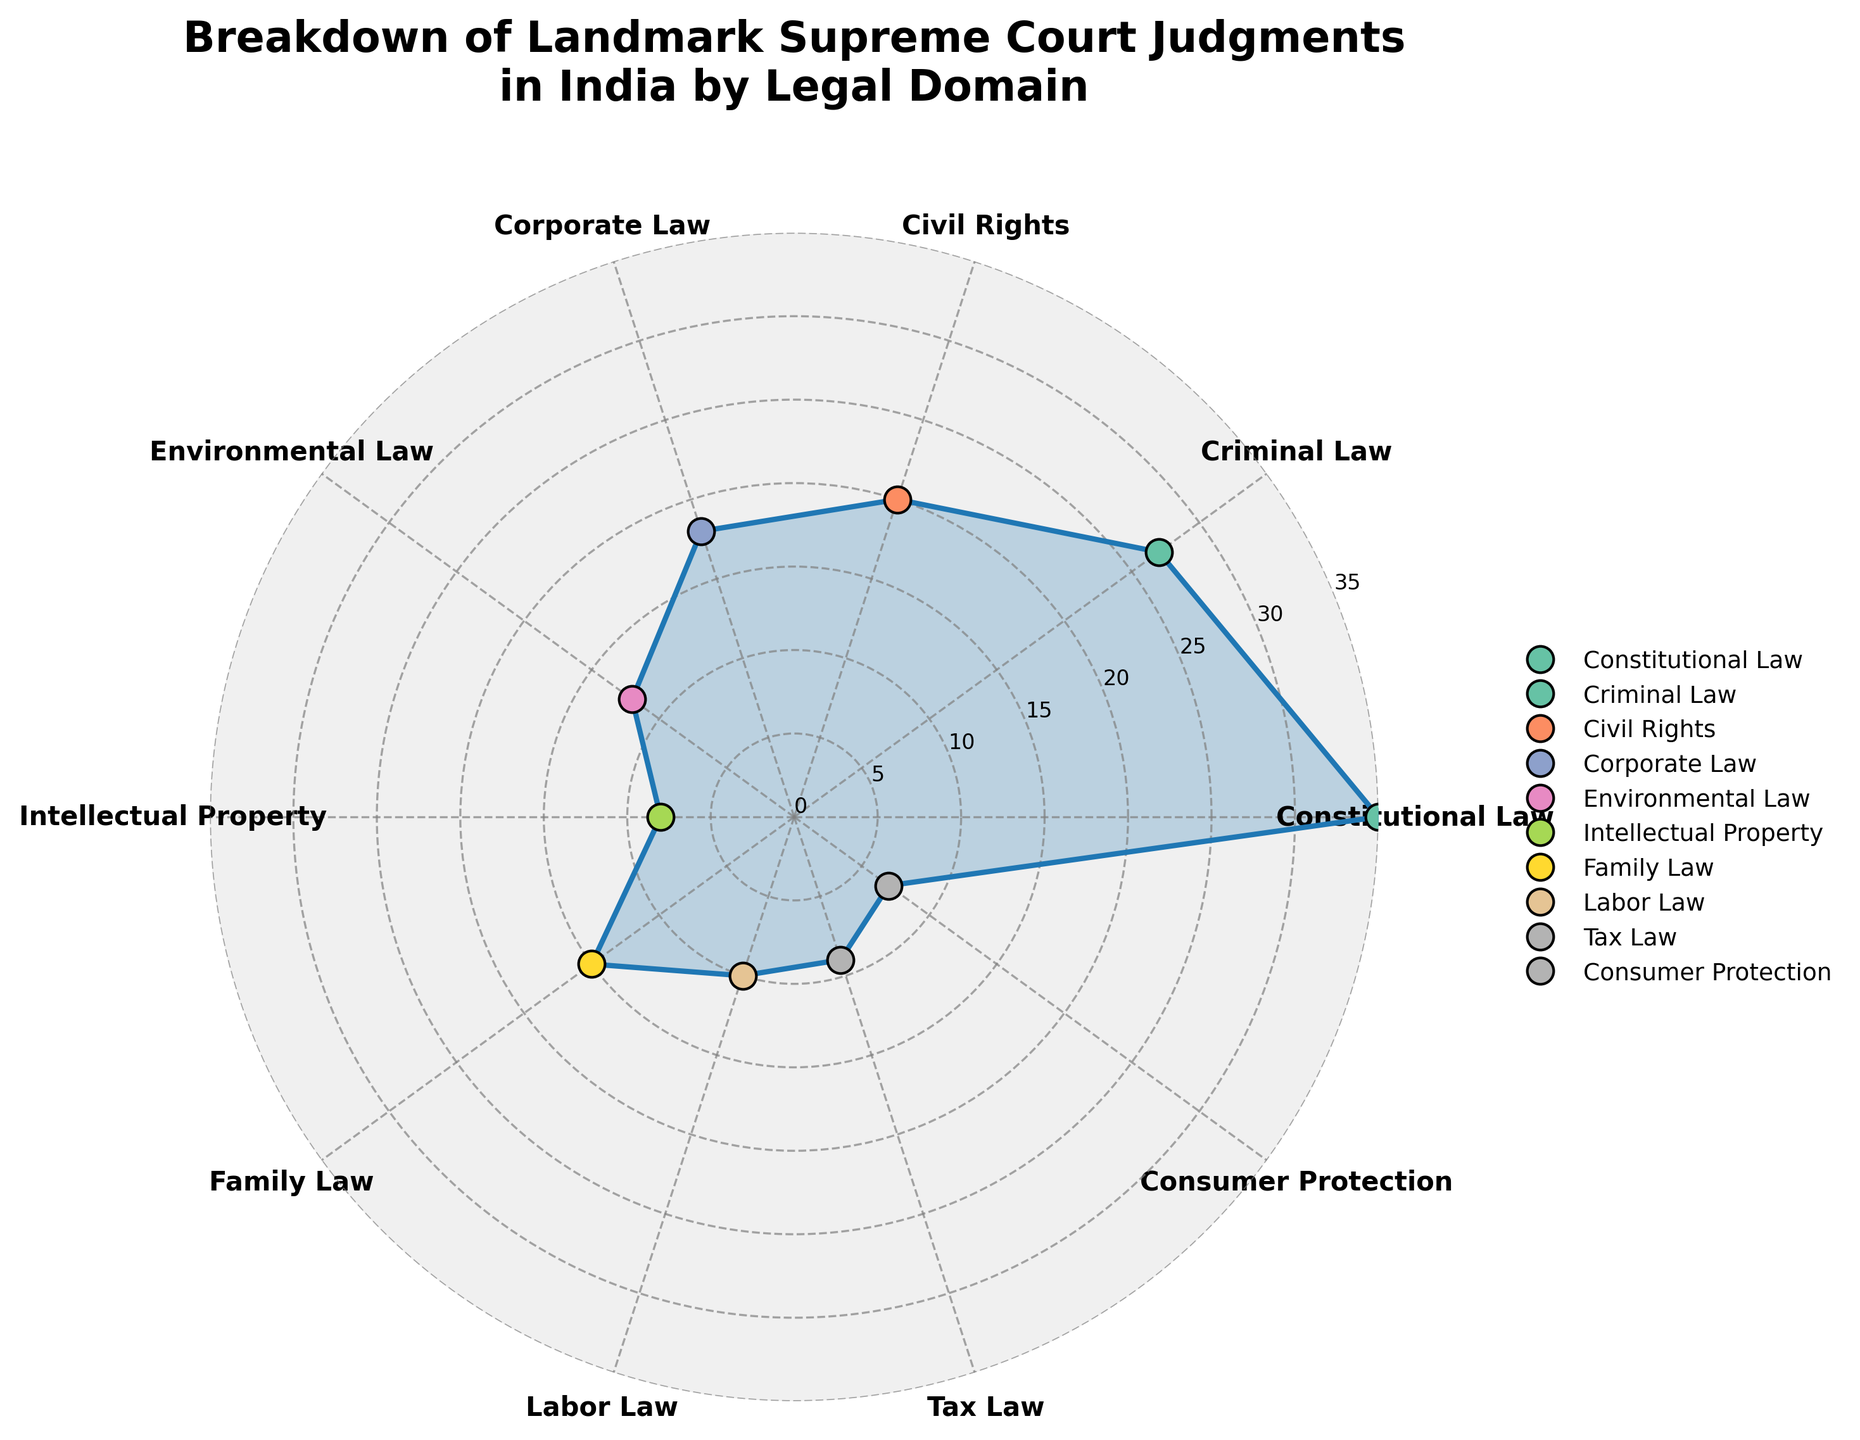What is the title of the figure? The title of the figure is prominently displayed at the top. It reads "Breakdown of Landmark Supreme Court Judgments in India by Legal Domain."
Answer: Breakdown of Landmark Supreme Court Judgments in India by Legal Domain How many legal domains are represented in the chart? By counting the labels around the polar area chart, you can see there are 10 different legal domains represented.
Answer: 10 Which legal domain has the highest number of landmark Supreme Court judgments? The segment with the largest length on the chart represents the legal domain with the highest number of judgments. This domain is labeled "Constitutional Law."
Answer: Constitutional Law What is the range of case counts for the legal domains shown in the chart? The range can be found by subtracting the smallest value (Consumer Protection, 7) from the largest value (Constitutional Law, 35).
Answer: 28 Which legal domains have fewer than 10 landmark Supreme Court judgments? From the plot, the labels with fewer than 10 judgments can be identified: Intellectual Property (8), Consumer Protection (7), and Tax Law (9).
Answer: Intellectual Property, Consumer Protection, and Tax Law How does the number of Criminal Law judgments compare to Environmental Law judgments? By observing the chart, Criminal Law has 27 judgments while Environmental Law has 12. Therefore, Criminal Law has more judgments.
Answer: Criminal Law has more judgments What is the median number of judgments among all legal domains? First, list the values: 35, 27, 20, 18, 15, 12, 10, 9, 8, 7. Since there are 10 values, the median will be the average of the 5th and 6th values in the ordered list: (15 + 12) / 2.
Answer: 13.5 How many legal domains have at least 20 landmark Supreme Court judgments? By observing the chart, Constitutional Law (35), Criminal Law (27), and Civil Rights (20) each have at least 20 judgments. Therefore, there are 3 domains.
Answer: 3 What is the total number of landmark Supreme Court judgments represented in this chart? Sum all the case counts: 35 + 27 + 20 + 18 + 12 + 8 + 15 + 10 + 9 + 7. The sum is 161.
Answer: 161 Which legal domain has the closest number of judgments to Family Law? Observing the chart, Family Law has 15 judgments. Labor Law has 10 judgments, which is the closest number to 15 among the other values.
Answer: Labor Law 